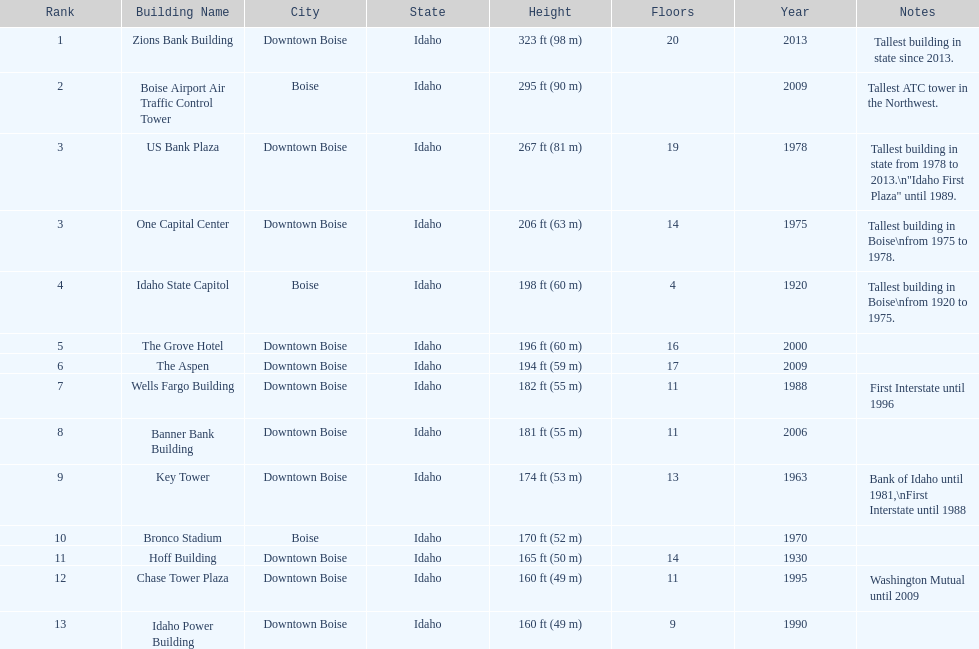How many floors does the tallest building have? 20. Write the full table. {'header': ['Rank', 'Building Name', 'City', 'State', 'Height', 'Floors', 'Year', 'Notes'], 'rows': [['1', 'Zions Bank Building', 'Downtown Boise', 'Idaho', '323\xa0ft (98\xa0m)', '20', '2013', 'Tallest building in state since 2013.'], ['2', 'Boise Airport Air Traffic Control Tower', 'Boise', 'Idaho', '295\xa0ft (90\xa0m)', '', '2009', 'Tallest ATC tower in the Northwest.'], ['3', 'US Bank Plaza', 'Downtown Boise', 'Idaho', '267\xa0ft (81\xa0m)', '19', '1978', 'Tallest building in state from 1978 to 2013.\\n"Idaho First Plaza" until 1989.'], ['3', 'One Capital Center', 'Downtown Boise', 'Idaho', '206\xa0ft (63\xa0m)', '14', '1975', 'Tallest building in Boise\\nfrom 1975 to 1978.'], ['4', 'Idaho State Capitol', 'Boise', 'Idaho', '198\xa0ft (60\xa0m)', '4', '1920', 'Tallest building in Boise\\nfrom 1920 to 1975.'], ['5', 'The Grove Hotel', 'Downtown Boise', 'Idaho', '196\xa0ft (60\xa0m)', '16', '2000', ''], ['6', 'The Aspen', 'Downtown Boise', 'Idaho', '194\xa0ft (59\xa0m)', '17', '2009', ''], ['7', 'Wells Fargo Building', 'Downtown Boise', 'Idaho', '182\xa0ft (55\xa0m)', '11', '1988', 'First Interstate until 1996'], ['8', 'Banner Bank Building', 'Downtown Boise', 'Idaho', '181\xa0ft (55\xa0m)', '11', '2006', ''], ['9', 'Key Tower', 'Downtown Boise', 'Idaho', '174\xa0ft (53\xa0m)', '13', '1963', 'Bank of Idaho until 1981,\\nFirst Interstate until 1988'], ['10', 'Bronco Stadium', 'Boise', 'Idaho', '170\xa0ft (52\xa0m)', '', '1970', ''], ['11', 'Hoff Building', 'Downtown Boise', 'Idaho', '165\xa0ft (50\xa0m)', '14', '1930', ''], ['12', 'Chase Tower Plaza', 'Downtown Boise', 'Idaho', '160\xa0ft (49\xa0m)', '11', '1995', 'Washington Mutual until 2009'], ['13', 'Idaho Power Building', 'Downtown Boise', 'Idaho', '160\xa0ft (49\xa0m)', '9', '1990', '']]} 